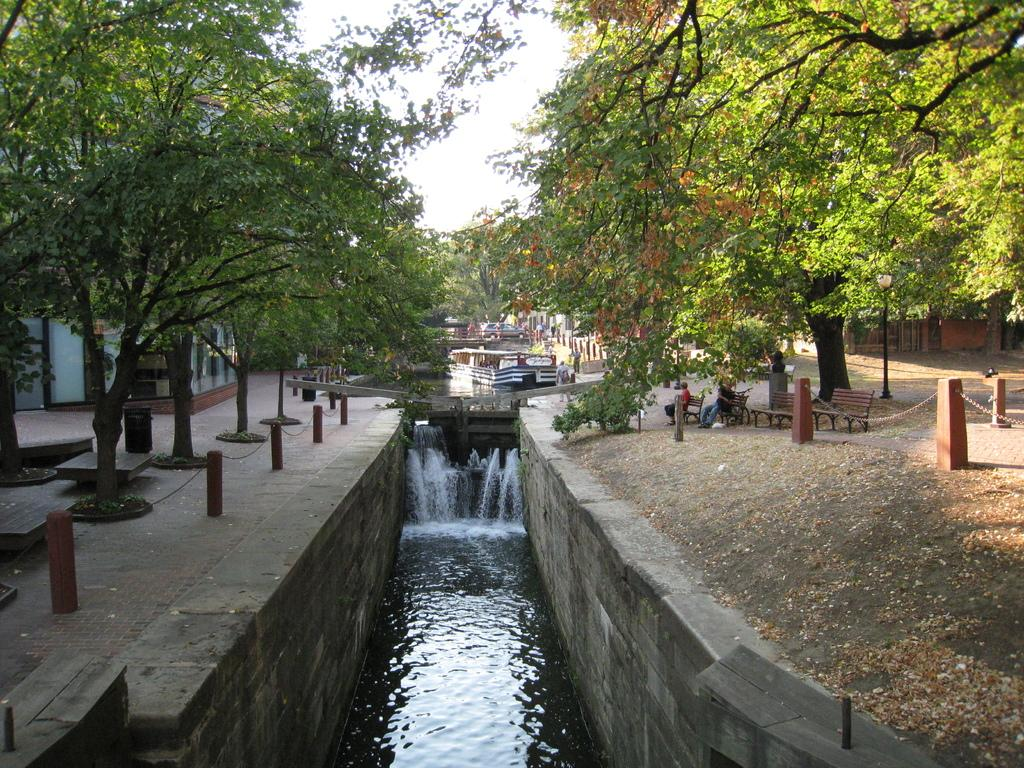What is one of the natural elements visible in the image? There is water visible in the image. What type of surface is present in the image? There is a floor in the image. What type of containers can be seen in the image? There are bins in the image. What type of seating is present in the image? There are benches in the image. What type of restraint is present in the image? There are chains in the image. What type of vehicle is present in the image? There is a car in the image. What type of structure is present in the image? There is a building in the image. What type of ground is visible in the image? The ground is visible in the image. What type of vertical structure is present in the image? There is a pole in the image. What type of illumination is present in the image? There is a light in the image. What type of vegetation is present in the image? There are trees in the image. What type of living beings are present in the image? There are people in the image. What type of unspecified objects are present in the image? There are various unspecified objects in the image. What type of celestial body is visible in the background of the image? The sky is visible in the background of the image. What type of creature is combing its fur in the image? There is no creature present in the image, and therefore no such activity can be observed. What type of afterthought is present in the image? There is no afterthought present in the image; the image is a direct representation of the scene. 